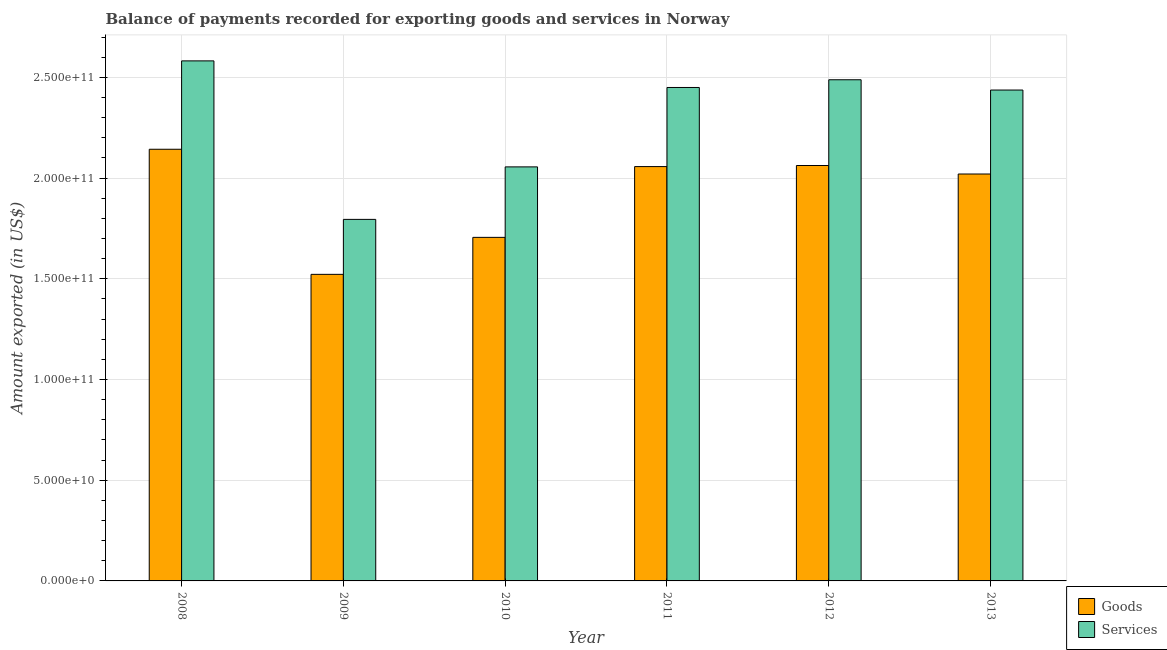How many groups of bars are there?
Keep it short and to the point. 6. How many bars are there on the 6th tick from the left?
Provide a succinct answer. 2. What is the amount of services exported in 2008?
Offer a very short reply. 2.58e+11. Across all years, what is the maximum amount of goods exported?
Keep it short and to the point. 2.14e+11. Across all years, what is the minimum amount of services exported?
Your response must be concise. 1.79e+11. In which year was the amount of services exported maximum?
Your answer should be compact. 2008. In which year was the amount of services exported minimum?
Offer a terse response. 2009. What is the total amount of services exported in the graph?
Your answer should be very brief. 1.38e+12. What is the difference between the amount of services exported in 2009 and that in 2013?
Give a very brief answer. -6.42e+1. What is the difference between the amount of goods exported in 2011 and the amount of services exported in 2008?
Give a very brief answer. -8.60e+09. What is the average amount of goods exported per year?
Your answer should be very brief. 1.92e+11. In the year 2008, what is the difference between the amount of goods exported and amount of services exported?
Keep it short and to the point. 0. What is the ratio of the amount of goods exported in 2009 to that in 2011?
Provide a short and direct response. 0.74. Is the amount of goods exported in 2008 less than that in 2012?
Give a very brief answer. No. What is the difference between the highest and the second highest amount of services exported?
Offer a terse response. 9.38e+09. What is the difference between the highest and the lowest amount of services exported?
Provide a short and direct response. 7.87e+1. In how many years, is the amount of goods exported greater than the average amount of goods exported taken over all years?
Provide a succinct answer. 4. What does the 2nd bar from the left in 2010 represents?
Offer a terse response. Services. What does the 2nd bar from the right in 2012 represents?
Offer a very short reply. Goods. How many bars are there?
Give a very brief answer. 12. How many years are there in the graph?
Give a very brief answer. 6. What is the difference between two consecutive major ticks on the Y-axis?
Make the answer very short. 5.00e+1. Are the values on the major ticks of Y-axis written in scientific E-notation?
Your response must be concise. Yes. Does the graph contain any zero values?
Provide a short and direct response. No. How are the legend labels stacked?
Offer a terse response. Vertical. What is the title of the graph?
Make the answer very short. Balance of payments recorded for exporting goods and services in Norway. Does "Nonresident" appear as one of the legend labels in the graph?
Keep it short and to the point. No. What is the label or title of the Y-axis?
Provide a succinct answer. Amount exported (in US$). What is the Amount exported (in US$) in Goods in 2008?
Your response must be concise. 2.14e+11. What is the Amount exported (in US$) in Services in 2008?
Offer a terse response. 2.58e+11. What is the Amount exported (in US$) in Goods in 2009?
Make the answer very short. 1.52e+11. What is the Amount exported (in US$) in Services in 2009?
Your answer should be compact. 1.79e+11. What is the Amount exported (in US$) in Goods in 2010?
Make the answer very short. 1.71e+11. What is the Amount exported (in US$) of Services in 2010?
Provide a short and direct response. 2.06e+11. What is the Amount exported (in US$) in Goods in 2011?
Provide a short and direct response. 2.06e+11. What is the Amount exported (in US$) of Services in 2011?
Your response must be concise. 2.45e+11. What is the Amount exported (in US$) of Goods in 2012?
Your response must be concise. 2.06e+11. What is the Amount exported (in US$) of Services in 2012?
Make the answer very short. 2.49e+11. What is the Amount exported (in US$) in Goods in 2013?
Ensure brevity in your answer.  2.02e+11. What is the Amount exported (in US$) in Services in 2013?
Provide a succinct answer. 2.44e+11. Across all years, what is the maximum Amount exported (in US$) of Goods?
Your answer should be compact. 2.14e+11. Across all years, what is the maximum Amount exported (in US$) of Services?
Offer a very short reply. 2.58e+11. Across all years, what is the minimum Amount exported (in US$) of Goods?
Ensure brevity in your answer.  1.52e+11. Across all years, what is the minimum Amount exported (in US$) in Services?
Give a very brief answer. 1.79e+11. What is the total Amount exported (in US$) of Goods in the graph?
Keep it short and to the point. 1.15e+12. What is the total Amount exported (in US$) in Services in the graph?
Give a very brief answer. 1.38e+12. What is the difference between the Amount exported (in US$) in Goods in 2008 and that in 2009?
Offer a very short reply. 6.21e+1. What is the difference between the Amount exported (in US$) in Services in 2008 and that in 2009?
Ensure brevity in your answer.  7.87e+1. What is the difference between the Amount exported (in US$) of Goods in 2008 and that in 2010?
Offer a very short reply. 4.37e+1. What is the difference between the Amount exported (in US$) in Services in 2008 and that in 2010?
Your answer should be compact. 5.26e+1. What is the difference between the Amount exported (in US$) in Goods in 2008 and that in 2011?
Ensure brevity in your answer.  8.60e+09. What is the difference between the Amount exported (in US$) in Services in 2008 and that in 2011?
Provide a succinct answer. 1.32e+1. What is the difference between the Amount exported (in US$) in Goods in 2008 and that in 2012?
Keep it short and to the point. 8.06e+09. What is the difference between the Amount exported (in US$) in Services in 2008 and that in 2012?
Provide a short and direct response. 9.38e+09. What is the difference between the Amount exported (in US$) in Goods in 2008 and that in 2013?
Provide a short and direct response. 1.23e+1. What is the difference between the Amount exported (in US$) in Services in 2008 and that in 2013?
Your response must be concise. 1.45e+1. What is the difference between the Amount exported (in US$) in Goods in 2009 and that in 2010?
Your response must be concise. -1.84e+1. What is the difference between the Amount exported (in US$) in Services in 2009 and that in 2010?
Keep it short and to the point. -2.61e+1. What is the difference between the Amount exported (in US$) in Goods in 2009 and that in 2011?
Provide a succinct answer. -5.35e+1. What is the difference between the Amount exported (in US$) of Services in 2009 and that in 2011?
Your answer should be compact. -6.55e+1. What is the difference between the Amount exported (in US$) of Goods in 2009 and that in 2012?
Make the answer very short. -5.40e+1. What is the difference between the Amount exported (in US$) in Services in 2009 and that in 2012?
Provide a short and direct response. -6.93e+1. What is the difference between the Amount exported (in US$) of Goods in 2009 and that in 2013?
Your answer should be compact. -4.98e+1. What is the difference between the Amount exported (in US$) in Services in 2009 and that in 2013?
Your response must be concise. -6.42e+1. What is the difference between the Amount exported (in US$) in Goods in 2010 and that in 2011?
Ensure brevity in your answer.  -3.51e+1. What is the difference between the Amount exported (in US$) in Services in 2010 and that in 2011?
Provide a short and direct response. -3.94e+1. What is the difference between the Amount exported (in US$) in Goods in 2010 and that in 2012?
Offer a very short reply. -3.57e+1. What is the difference between the Amount exported (in US$) in Services in 2010 and that in 2012?
Your answer should be compact. -4.33e+1. What is the difference between the Amount exported (in US$) of Goods in 2010 and that in 2013?
Give a very brief answer. -3.15e+1. What is the difference between the Amount exported (in US$) in Services in 2010 and that in 2013?
Provide a succinct answer. -3.82e+1. What is the difference between the Amount exported (in US$) in Goods in 2011 and that in 2012?
Offer a very short reply. -5.37e+08. What is the difference between the Amount exported (in US$) in Services in 2011 and that in 2012?
Provide a succinct answer. -3.83e+09. What is the difference between the Amount exported (in US$) of Goods in 2011 and that in 2013?
Offer a very short reply. 3.69e+09. What is the difference between the Amount exported (in US$) of Services in 2011 and that in 2013?
Your answer should be compact. 1.27e+09. What is the difference between the Amount exported (in US$) in Goods in 2012 and that in 2013?
Your answer should be compact. 4.22e+09. What is the difference between the Amount exported (in US$) in Services in 2012 and that in 2013?
Your answer should be compact. 5.10e+09. What is the difference between the Amount exported (in US$) of Goods in 2008 and the Amount exported (in US$) of Services in 2009?
Offer a very short reply. 3.48e+1. What is the difference between the Amount exported (in US$) of Goods in 2008 and the Amount exported (in US$) of Services in 2010?
Provide a short and direct response. 8.75e+09. What is the difference between the Amount exported (in US$) in Goods in 2008 and the Amount exported (in US$) in Services in 2011?
Keep it short and to the point. -3.07e+1. What is the difference between the Amount exported (in US$) of Goods in 2008 and the Amount exported (in US$) of Services in 2012?
Keep it short and to the point. -3.45e+1. What is the difference between the Amount exported (in US$) of Goods in 2008 and the Amount exported (in US$) of Services in 2013?
Keep it short and to the point. -2.94e+1. What is the difference between the Amount exported (in US$) of Goods in 2009 and the Amount exported (in US$) of Services in 2010?
Give a very brief answer. -5.34e+1. What is the difference between the Amount exported (in US$) of Goods in 2009 and the Amount exported (in US$) of Services in 2011?
Make the answer very short. -9.28e+1. What is the difference between the Amount exported (in US$) of Goods in 2009 and the Amount exported (in US$) of Services in 2012?
Your response must be concise. -9.66e+1. What is the difference between the Amount exported (in US$) in Goods in 2009 and the Amount exported (in US$) in Services in 2013?
Make the answer very short. -9.15e+1. What is the difference between the Amount exported (in US$) in Goods in 2010 and the Amount exported (in US$) in Services in 2011?
Offer a very short reply. -7.44e+1. What is the difference between the Amount exported (in US$) of Goods in 2010 and the Amount exported (in US$) of Services in 2012?
Ensure brevity in your answer.  -7.82e+1. What is the difference between the Amount exported (in US$) of Goods in 2010 and the Amount exported (in US$) of Services in 2013?
Ensure brevity in your answer.  -7.31e+1. What is the difference between the Amount exported (in US$) of Goods in 2011 and the Amount exported (in US$) of Services in 2012?
Your answer should be compact. -4.31e+1. What is the difference between the Amount exported (in US$) in Goods in 2011 and the Amount exported (in US$) in Services in 2013?
Ensure brevity in your answer.  -3.80e+1. What is the difference between the Amount exported (in US$) of Goods in 2012 and the Amount exported (in US$) of Services in 2013?
Ensure brevity in your answer.  -3.75e+1. What is the average Amount exported (in US$) in Goods per year?
Your answer should be compact. 1.92e+11. What is the average Amount exported (in US$) in Services per year?
Your answer should be compact. 2.30e+11. In the year 2008, what is the difference between the Amount exported (in US$) in Goods and Amount exported (in US$) in Services?
Ensure brevity in your answer.  -4.39e+1. In the year 2009, what is the difference between the Amount exported (in US$) in Goods and Amount exported (in US$) in Services?
Give a very brief answer. -2.73e+1. In the year 2010, what is the difference between the Amount exported (in US$) of Goods and Amount exported (in US$) of Services?
Keep it short and to the point. -3.50e+1. In the year 2011, what is the difference between the Amount exported (in US$) in Goods and Amount exported (in US$) in Services?
Provide a short and direct response. -3.93e+1. In the year 2012, what is the difference between the Amount exported (in US$) in Goods and Amount exported (in US$) in Services?
Make the answer very short. -4.26e+1. In the year 2013, what is the difference between the Amount exported (in US$) in Goods and Amount exported (in US$) in Services?
Give a very brief answer. -4.17e+1. What is the ratio of the Amount exported (in US$) of Goods in 2008 to that in 2009?
Ensure brevity in your answer.  1.41. What is the ratio of the Amount exported (in US$) in Services in 2008 to that in 2009?
Your answer should be very brief. 1.44. What is the ratio of the Amount exported (in US$) in Goods in 2008 to that in 2010?
Provide a succinct answer. 1.26. What is the ratio of the Amount exported (in US$) in Services in 2008 to that in 2010?
Offer a terse response. 1.26. What is the ratio of the Amount exported (in US$) in Goods in 2008 to that in 2011?
Provide a succinct answer. 1.04. What is the ratio of the Amount exported (in US$) of Services in 2008 to that in 2011?
Your answer should be compact. 1.05. What is the ratio of the Amount exported (in US$) of Goods in 2008 to that in 2012?
Make the answer very short. 1.04. What is the ratio of the Amount exported (in US$) in Services in 2008 to that in 2012?
Your response must be concise. 1.04. What is the ratio of the Amount exported (in US$) in Goods in 2008 to that in 2013?
Keep it short and to the point. 1.06. What is the ratio of the Amount exported (in US$) of Services in 2008 to that in 2013?
Keep it short and to the point. 1.06. What is the ratio of the Amount exported (in US$) of Goods in 2009 to that in 2010?
Your answer should be compact. 0.89. What is the ratio of the Amount exported (in US$) of Services in 2009 to that in 2010?
Your answer should be compact. 0.87. What is the ratio of the Amount exported (in US$) of Goods in 2009 to that in 2011?
Offer a terse response. 0.74. What is the ratio of the Amount exported (in US$) of Services in 2009 to that in 2011?
Ensure brevity in your answer.  0.73. What is the ratio of the Amount exported (in US$) in Goods in 2009 to that in 2012?
Offer a very short reply. 0.74. What is the ratio of the Amount exported (in US$) in Services in 2009 to that in 2012?
Give a very brief answer. 0.72. What is the ratio of the Amount exported (in US$) in Goods in 2009 to that in 2013?
Offer a very short reply. 0.75. What is the ratio of the Amount exported (in US$) of Services in 2009 to that in 2013?
Provide a succinct answer. 0.74. What is the ratio of the Amount exported (in US$) of Goods in 2010 to that in 2011?
Make the answer very short. 0.83. What is the ratio of the Amount exported (in US$) in Services in 2010 to that in 2011?
Provide a succinct answer. 0.84. What is the ratio of the Amount exported (in US$) of Goods in 2010 to that in 2012?
Ensure brevity in your answer.  0.83. What is the ratio of the Amount exported (in US$) of Services in 2010 to that in 2012?
Offer a terse response. 0.83. What is the ratio of the Amount exported (in US$) in Goods in 2010 to that in 2013?
Your answer should be compact. 0.84. What is the ratio of the Amount exported (in US$) of Services in 2010 to that in 2013?
Offer a terse response. 0.84. What is the ratio of the Amount exported (in US$) in Goods in 2011 to that in 2012?
Provide a succinct answer. 1. What is the ratio of the Amount exported (in US$) in Services in 2011 to that in 2012?
Offer a very short reply. 0.98. What is the ratio of the Amount exported (in US$) in Goods in 2011 to that in 2013?
Make the answer very short. 1.02. What is the ratio of the Amount exported (in US$) of Services in 2011 to that in 2013?
Provide a succinct answer. 1.01. What is the ratio of the Amount exported (in US$) of Goods in 2012 to that in 2013?
Give a very brief answer. 1.02. What is the ratio of the Amount exported (in US$) in Services in 2012 to that in 2013?
Provide a succinct answer. 1.02. What is the difference between the highest and the second highest Amount exported (in US$) in Goods?
Provide a succinct answer. 8.06e+09. What is the difference between the highest and the second highest Amount exported (in US$) of Services?
Your answer should be compact. 9.38e+09. What is the difference between the highest and the lowest Amount exported (in US$) of Goods?
Provide a short and direct response. 6.21e+1. What is the difference between the highest and the lowest Amount exported (in US$) in Services?
Provide a succinct answer. 7.87e+1. 